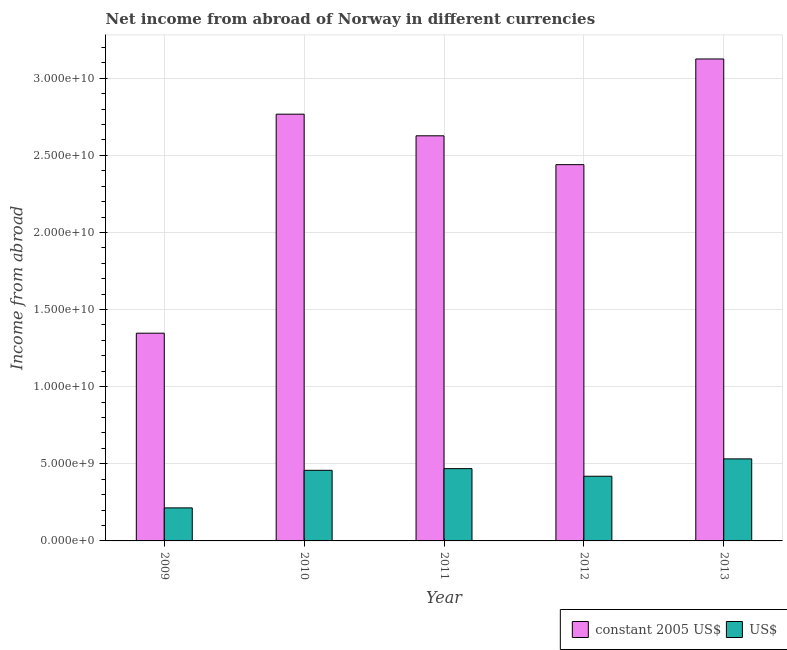Are the number of bars per tick equal to the number of legend labels?
Your answer should be compact. Yes. Are the number of bars on each tick of the X-axis equal?
Your answer should be compact. Yes. What is the income from abroad in constant 2005 us$ in 2013?
Keep it short and to the point. 3.12e+1. Across all years, what is the maximum income from abroad in us$?
Give a very brief answer. 5.32e+09. Across all years, what is the minimum income from abroad in constant 2005 us$?
Keep it short and to the point. 1.35e+1. What is the total income from abroad in constant 2005 us$ in the graph?
Ensure brevity in your answer.  1.23e+11. What is the difference between the income from abroad in us$ in 2009 and that in 2013?
Your response must be concise. -3.18e+09. What is the difference between the income from abroad in constant 2005 us$ in 2011 and the income from abroad in us$ in 2010?
Keep it short and to the point. -1.40e+09. What is the average income from abroad in constant 2005 us$ per year?
Ensure brevity in your answer.  2.46e+1. In how many years, is the income from abroad in us$ greater than 9000000000 units?
Give a very brief answer. 0. What is the ratio of the income from abroad in us$ in 2009 to that in 2010?
Provide a short and direct response. 0.47. Is the income from abroad in us$ in 2009 less than that in 2013?
Offer a very short reply. Yes. What is the difference between the highest and the second highest income from abroad in us$?
Give a very brief answer. 6.32e+08. What is the difference between the highest and the lowest income from abroad in us$?
Your response must be concise. 3.18e+09. In how many years, is the income from abroad in constant 2005 us$ greater than the average income from abroad in constant 2005 us$ taken over all years?
Provide a succinct answer. 3. What does the 1st bar from the left in 2011 represents?
Your answer should be compact. Constant 2005 us$. What does the 2nd bar from the right in 2009 represents?
Keep it short and to the point. Constant 2005 us$. How many years are there in the graph?
Provide a succinct answer. 5. Are the values on the major ticks of Y-axis written in scientific E-notation?
Make the answer very short. Yes. Does the graph contain any zero values?
Offer a terse response. No. Where does the legend appear in the graph?
Your answer should be very brief. Bottom right. What is the title of the graph?
Your response must be concise. Net income from abroad of Norway in different currencies. What is the label or title of the Y-axis?
Your response must be concise. Income from abroad. What is the Income from abroad of constant 2005 US$ in 2009?
Provide a succinct answer. 1.35e+1. What is the Income from abroad of US$ in 2009?
Your answer should be compact. 2.14e+09. What is the Income from abroad of constant 2005 US$ in 2010?
Your answer should be compact. 2.77e+1. What is the Income from abroad in US$ in 2010?
Make the answer very short. 4.58e+09. What is the Income from abroad in constant 2005 US$ in 2011?
Keep it short and to the point. 2.63e+1. What is the Income from abroad of US$ in 2011?
Provide a short and direct response. 4.69e+09. What is the Income from abroad in constant 2005 US$ in 2012?
Make the answer very short. 2.44e+1. What is the Income from abroad of US$ in 2012?
Offer a terse response. 4.19e+09. What is the Income from abroad of constant 2005 US$ in 2013?
Your answer should be compact. 3.12e+1. What is the Income from abroad in US$ in 2013?
Keep it short and to the point. 5.32e+09. Across all years, what is the maximum Income from abroad of constant 2005 US$?
Provide a succinct answer. 3.12e+1. Across all years, what is the maximum Income from abroad of US$?
Provide a short and direct response. 5.32e+09. Across all years, what is the minimum Income from abroad of constant 2005 US$?
Your answer should be very brief. 1.35e+1. Across all years, what is the minimum Income from abroad of US$?
Your response must be concise. 2.14e+09. What is the total Income from abroad in constant 2005 US$ in the graph?
Make the answer very short. 1.23e+11. What is the total Income from abroad of US$ in the graph?
Your answer should be very brief. 2.09e+1. What is the difference between the Income from abroad in constant 2005 US$ in 2009 and that in 2010?
Provide a short and direct response. -1.42e+1. What is the difference between the Income from abroad of US$ in 2009 and that in 2010?
Make the answer very short. -2.44e+09. What is the difference between the Income from abroad in constant 2005 US$ in 2009 and that in 2011?
Give a very brief answer. -1.28e+1. What is the difference between the Income from abroad in US$ in 2009 and that in 2011?
Offer a very short reply. -2.54e+09. What is the difference between the Income from abroad of constant 2005 US$ in 2009 and that in 2012?
Your response must be concise. -1.09e+1. What is the difference between the Income from abroad in US$ in 2009 and that in 2012?
Make the answer very short. -2.05e+09. What is the difference between the Income from abroad in constant 2005 US$ in 2009 and that in 2013?
Keep it short and to the point. -1.78e+1. What is the difference between the Income from abroad of US$ in 2009 and that in 2013?
Offer a very short reply. -3.18e+09. What is the difference between the Income from abroad in constant 2005 US$ in 2010 and that in 2011?
Your response must be concise. 1.40e+09. What is the difference between the Income from abroad in US$ in 2010 and that in 2011?
Ensure brevity in your answer.  -1.09e+08. What is the difference between the Income from abroad of constant 2005 US$ in 2010 and that in 2012?
Offer a terse response. 3.27e+09. What is the difference between the Income from abroad in US$ in 2010 and that in 2012?
Offer a very short reply. 3.84e+08. What is the difference between the Income from abroad of constant 2005 US$ in 2010 and that in 2013?
Offer a very short reply. -3.58e+09. What is the difference between the Income from abroad of US$ in 2010 and that in 2013?
Provide a succinct answer. -7.41e+08. What is the difference between the Income from abroad of constant 2005 US$ in 2011 and that in 2012?
Offer a terse response. 1.87e+09. What is the difference between the Income from abroad in US$ in 2011 and that in 2012?
Ensure brevity in your answer.  4.93e+08. What is the difference between the Income from abroad of constant 2005 US$ in 2011 and that in 2013?
Your answer should be compact. -4.98e+09. What is the difference between the Income from abroad of US$ in 2011 and that in 2013?
Make the answer very short. -6.32e+08. What is the difference between the Income from abroad of constant 2005 US$ in 2012 and that in 2013?
Your answer should be compact. -6.85e+09. What is the difference between the Income from abroad in US$ in 2012 and that in 2013?
Offer a terse response. -1.13e+09. What is the difference between the Income from abroad of constant 2005 US$ in 2009 and the Income from abroad of US$ in 2010?
Your response must be concise. 8.89e+09. What is the difference between the Income from abroad of constant 2005 US$ in 2009 and the Income from abroad of US$ in 2011?
Your response must be concise. 8.78e+09. What is the difference between the Income from abroad in constant 2005 US$ in 2009 and the Income from abroad in US$ in 2012?
Give a very brief answer. 9.27e+09. What is the difference between the Income from abroad of constant 2005 US$ in 2009 and the Income from abroad of US$ in 2013?
Keep it short and to the point. 8.15e+09. What is the difference between the Income from abroad in constant 2005 US$ in 2010 and the Income from abroad in US$ in 2011?
Offer a very short reply. 2.30e+1. What is the difference between the Income from abroad in constant 2005 US$ in 2010 and the Income from abroad in US$ in 2012?
Your response must be concise. 2.35e+1. What is the difference between the Income from abroad in constant 2005 US$ in 2010 and the Income from abroad in US$ in 2013?
Your answer should be compact. 2.23e+1. What is the difference between the Income from abroad of constant 2005 US$ in 2011 and the Income from abroad of US$ in 2012?
Offer a very short reply. 2.21e+1. What is the difference between the Income from abroad in constant 2005 US$ in 2011 and the Income from abroad in US$ in 2013?
Your answer should be very brief. 2.09e+1. What is the difference between the Income from abroad in constant 2005 US$ in 2012 and the Income from abroad in US$ in 2013?
Offer a terse response. 1.91e+1. What is the average Income from abroad of constant 2005 US$ per year?
Offer a very short reply. 2.46e+1. What is the average Income from abroad of US$ per year?
Your response must be concise. 4.18e+09. In the year 2009, what is the difference between the Income from abroad of constant 2005 US$ and Income from abroad of US$?
Your answer should be very brief. 1.13e+1. In the year 2010, what is the difference between the Income from abroad of constant 2005 US$ and Income from abroad of US$?
Your response must be concise. 2.31e+1. In the year 2011, what is the difference between the Income from abroad in constant 2005 US$ and Income from abroad in US$?
Provide a succinct answer. 2.16e+1. In the year 2012, what is the difference between the Income from abroad in constant 2005 US$ and Income from abroad in US$?
Offer a very short reply. 2.02e+1. In the year 2013, what is the difference between the Income from abroad of constant 2005 US$ and Income from abroad of US$?
Ensure brevity in your answer.  2.59e+1. What is the ratio of the Income from abroad of constant 2005 US$ in 2009 to that in 2010?
Your answer should be compact. 0.49. What is the ratio of the Income from abroad of US$ in 2009 to that in 2010?
Your answer should be compact. 0.47. What is the ratio of the Income from abroad of constant 2005 US$ in 2009 to that in 2011?
Give a very brief answer. 0.51. What is the ratio of the Income from abroad of US$ in 2009 to that in 2011?
Provide a short and direct response. 0.46. What is the ratio of the Income from abroad of constant 2005 US$ in 2009 to that in 2012?
Offer a very short reply. 0.55. What is the ratio of the Income from abroad of US$ in 2009 to that in 2012?
Provide a short and direct response. 0.51. What is the ratio of the Income from abroad in constant 2005 US$ in 2009 to that in 2013?
Provide a succinct answer. 0.43. What is the ratio of the Income from abroad of US$ in 2009 to that in 2013?
Your answer should be compact. 0.4. What is the ratio of the Income from abroad of constant 2005 US$ in 2010 to that in 2011?
Make the answer very short. 1.05. What is the ratio of the Income from abroad in US$ in 2010 to that in 2011?
Make the answer very short. 0.98. What is the ratio of the Income from abroad of constant 2005 US$ in 2010 to that in 2012?
Your response must be concise. 1.13. What is the ratio of the Income from abroad of US$ in 2010 to that in 2012?
Your response must be concise. 1.09. What is the ratio of the Income from abroad in constant 2005 US$ in 2010 to that in 2013?
Keep it short and to the point. 0.89. What is the ratio of the Income from abroad in US$ in 2010 to that in 2013?
Your answer should be very brief. 0.86. What is the ratio of the Income from abroad in constant 2005 US$ in 2011 to that in 2012?
Your answer should be compact. 1.08. What is the ratio of the Income from abroad of US$ in 2011 to that in 2012?
Your response must be concise. 1.12. What is the ratio of the Income from abroad in constant 2005 US$ in 2011 to that in 2013?
Give a very brief answer. 0.84. What is the ratio of the Income from abroad in US$ in 2011 to that in 2013?
Offer a very short reply. 0.88. What is the ratio of the Income from abroad in constant 2005 US$ in 2012 to that in 2013?
Provide a short and direct response. 0.78. What is the ratio of the Income from abroad in US$ in 2012 to that in 2013?
Ensure brevity in your answer.  0.79. What is the difference between the highest and the second highest Income from abroad in constant 2005 US$?
Offer a terse response. 3.58e+09. What is the difference between the highest and the second highest Income from abroad in US$?
Give a very brief answer. 6.32e+08. What is the difference between the highest and the lowest Income from abroad of constant 2005 US$?
Your answer should be compact. 1.78e+1. What is the difference between the highest and the lowest Income from abroad of US$?
Make the answer very short. 3.18e+09. 